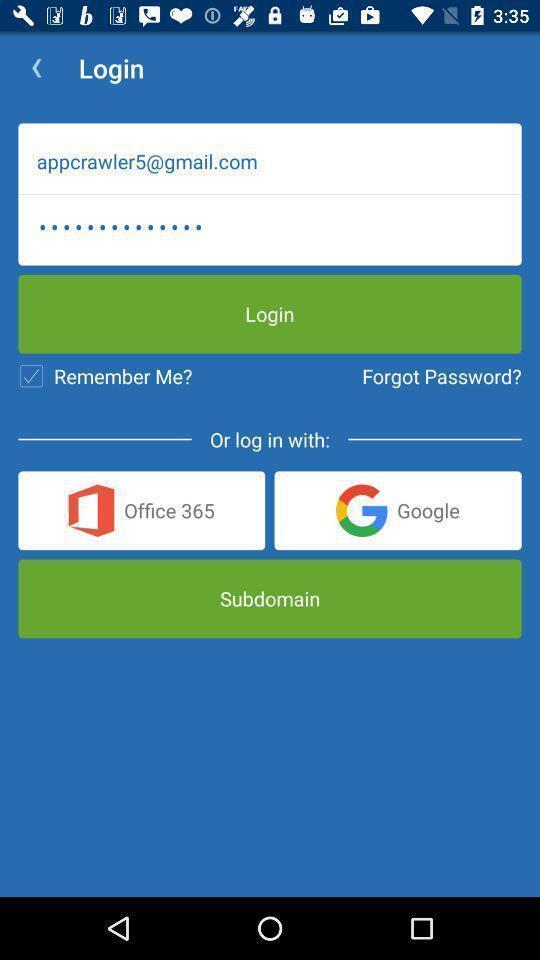Describe the key features of this screenshot. Page displaying signing in information about an educational application. 